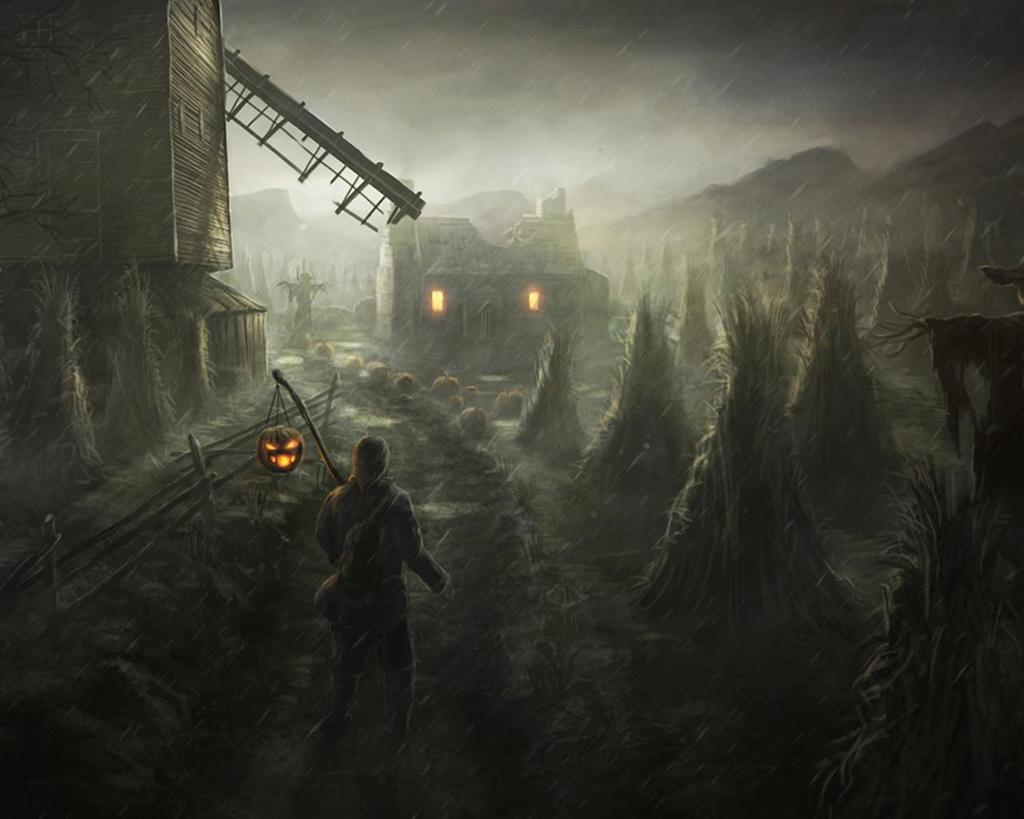What type of image is being described? The image is animated. Can you describe the person in the image? There is a person standing in the image, and they are holding a pumpkin light. What kind of structures are present in the image? There are houses in the image. What other objects or elements can be seen in the image? There are pumpkins and trees in the image. What type of lunchroom can be seen in the image? There is no lunchroom present in the image; it features an animated scene with a person holding a pumpkin light, houses, pumpkins, and trees. 